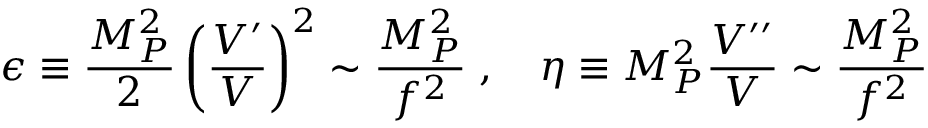Convert formula to latex. <formula><loc_0><loc_0><loc_500><loc_500>\epsilon \equiv \frac { M _ { P } ^ { 2 } } { 2 } \left ( \frac { V ^ { \prime } } { V } \right ) ^ { 2 } \sim \frac { M _ { P } ^ { 2 } } { f ^ { 2 } } \, , \quad \eta \equiv M _ { P } ^ { 2 } \frac { V ^ { \prime \prime } } { V } \sim \frac { M _ { P } ^ { 2 } } { f ^ { 2 } }</formula> 